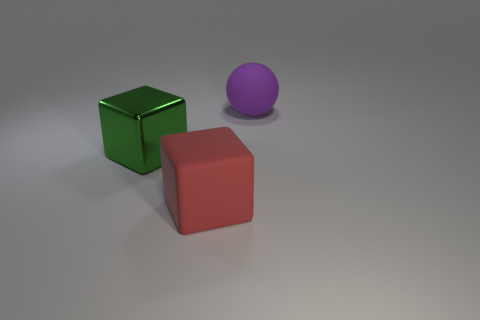There is a red block that is made of the same material as the large purple thing; what is its size?
Offer a terse response. Large. What number of things are either matte objects in front of the purple ball or big red things?
Provide a succinct answer. 1. What is the color of the rubber object that is right of the large matte object to the left of the big matte object behind the big red thing?
Your answer should be compact. Purple. Is the big ball made of the same material as the large red object?
Ensure brevity in your answer.  Yes. There is a large rubber thing that is left of the rubber thing behind the shiny cube; is there a big block that is behind it?
Your response must be concise. Yes. Is the number of tiny yellow cylinders less than the number of red matte objects?
Your answer should be very brief. Yes. Do the block behind the big red thing and the block on the right side of the metal object have the same material?
Your answer should be very brief. No. Is the number of large objects right of the large rubber block less than the number of purple rubber spheres?
Your response must be concise. No. How many green cubes are to the left of the large red object that is to the right of the big green metallic cube?
Offer a terse response. 1. What is the size of the object that is both behind the big matte cube and to the right of the large green thing?
Offer a very short reply. Large. 